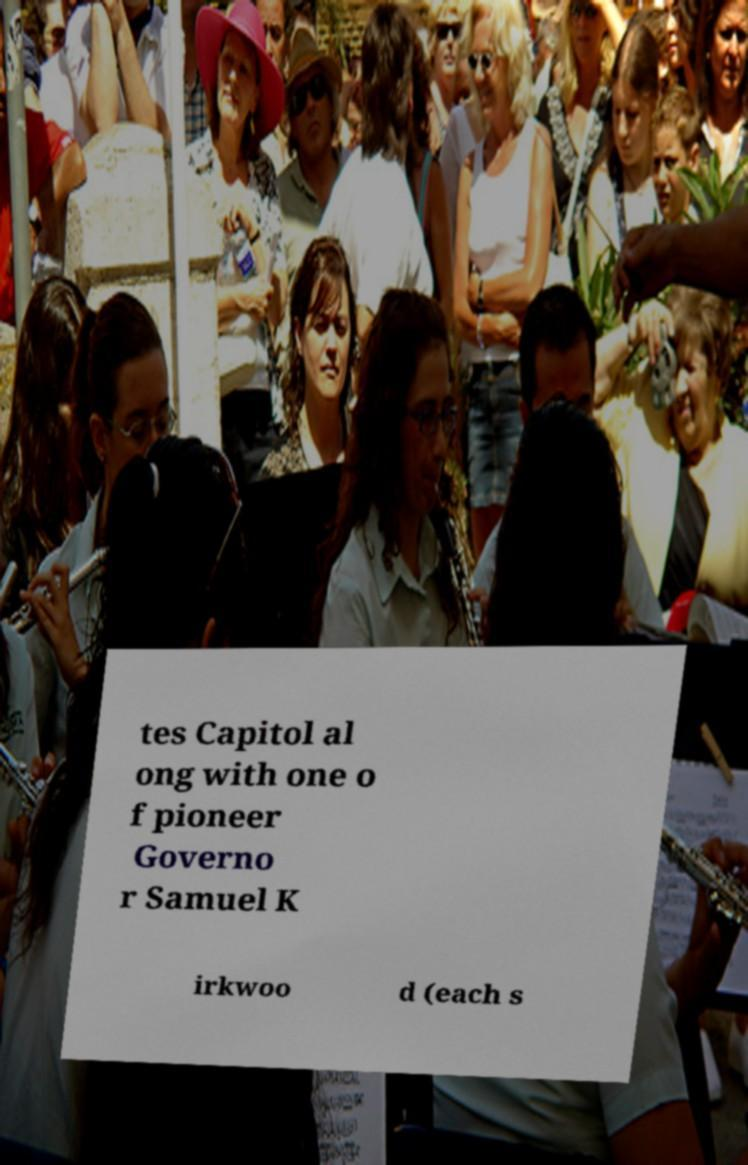For documentation purposes, I need the text within this image transcribed. Could you provide that? tes Capitol al ong with one o f pioneer Governo r Samuel K irkwoo d (each s 